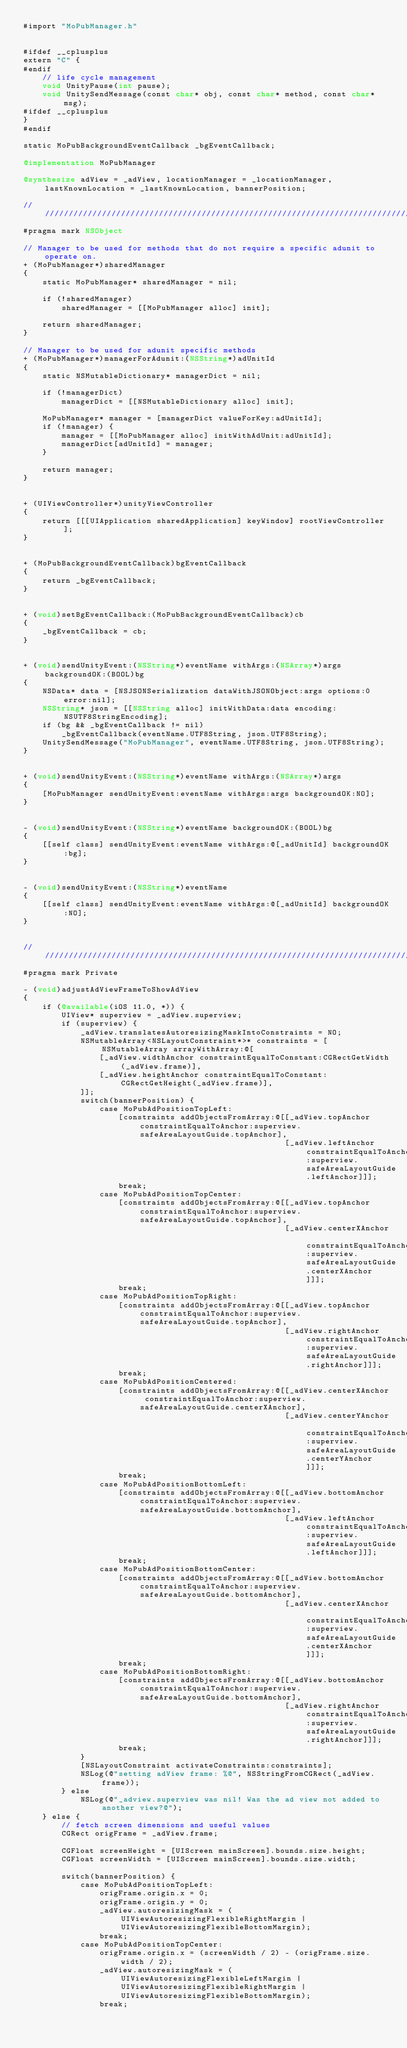<code> <loc_0><loc_0><loc_500><loc_500><_ObjectiveC_>#import "MoPubManager.h"


#ifdef __cplusplus
extern "C" {
#endif
    // life cycle management
    void UnityPause(int pause);
    void UnitySendMessage(const char* obj, const char* method, const char* msg);
#ifdef __cplusplus
}
#endif

static MoPubBackgroundEventCallback _bgEventCallback;

@implementation MoPubManager

@synthesize adView = _adView, locationManager = _locationManager, lastKnownLocation = _lastKnownLocation, bannerPosition;

///////////////////////////////////////////////////////////////////////////////////////////////////
#pragma mark NSObject

// Manager to be used for methods that do not require a specific adunit to operate on.
+ (MoPubManager*)sharedManager
{
    static MoPubManager* sharedManager = nil;

    if (!sharedManager)
        sharedManager = [[MoPubManager alloc] init];

    return sharedManager;
}

// Manager to be used for adunit specific methods
+ (MoPubManager*)managerForAdunit:(NSString*)adUnitId
{
    static NSMutableDictionary* managerDict = nil;

    if (!managerDict)
        managerDict = [[NSMutableDictionary alloc] init];

    MoPubManager* manager = [managerDict valueForKey:adUnitId];
    if (!manager) {
        manager = [[MoPubManager alloc] initWithAdUnit:adUnitId];
        managerDict[adUnitId] = manager;
    }

    return manager;
}


+ (UIViewController*)unityViewController
{
    return [[[UIApplication sharedApplication] keyWindow] rootViewController];
}


+ (MoPubBackgroundEventCallback)bgEventCallback
{
    return _bgEventCallback;
}


+ (void)setBgEventCallback:(MoPubBackgroundEventCallback)cb
{
    _bgEventCallback = cb;
}


+ (void)sendUnityEvent:(NSString*)eventName withArgs:(NSArray*)args backgroundOK:(BOOL)bg
{
    NSData* data = [NSJSONSerialization dataWithJSONObject:args options:0 error:nil];
    NSString* json = [[NSString alloc] initWithData:data encoding:NSUTF8StringEncoding];
    if (bg && _bgEventCallback != nil)
        _bgEventCallback(eventName.UTF8String, json.UTF8String);
    UnitySendMessage("MoPubManager", eventName.UTF8String, json.UTF8String);
}


+ (void)sendUnityEvent:(NSString*)eventName withArgs:(NSArray*)args
{
    [MoPubManager sendUnityEvent:eventName withArgs:args backgroundOK:NO];
}


- (void)sendUnityEvent:(NSString*)eventName backgroundOK:(BOOL)bg
{
    [[self class] sendUnityEvent:eventName withArgs:@[_adUnitId] backgroundOK:bg];
}


- (void)sendUnityEvent:(NSString*)eventName
{
    [[self class] sendUnityEvent:eventName withArgs:@[_adUnitId] backgroundOK:NO];
}


///////////////////////////////////////////////////////////////////////////////////////////////////
#pragma mark Private

- (void)adjustAdViewFrameToShowAdView
{
    if (@available(iOS 11.0, *)) {
        UIView* superview = _adView.superview;
        if (superview) {
            _adView.translatesAutoresizingMaskIntoConstraints = NO;
            NSMutableArray<NSLayoutConstraint*>* constraints = [NSMutableArray arrayWithArray:@[
                [_adView.widthAnchor constraintEqualToConstant:CGRectGetWidth(_adView.frame)],
                [_adView.heightAnchor constraintEqualToConstant:CGRectGetHeight(_adView.frame)],
            ]];
            switch(bannerPosition) {
                case MoPubAdPositionTopLeft:
                    [constraints addObjectsFromArray:@[[_adView.topAnchor constraintEqualToAnchor:superview.safeAreaLayoutGuide.topAnchor],
                                                       [_adView.leftAnchor constraintEqualToAnchor:superview.safeAreaLayoutGuide.leftAnchor]]];
                    break;
                case MoPubAdPositionTopCenter:
                    [constraints addObjectsFromArray:@[[_adView.topAnchor constraintEqualToAnchor:superview.safeAreaLayoutGuide.topAnchor],
                                                       [_adView.centerXAnchor constraintEqualToAnchor:superview.safeAreaLayoutGuide.centerXAnchor]]];
                    break;
                case MoPubAdPositionTopRight:
                    [constraints addObjectsFromArray:@[[_adView.topAnchor constraintEqualToAnchor:superview.safeAreaLayoutGuide.topAnchor],
                                                       [_adView.rightAnchor constraintEqualToAnchor:superview.safeAreaLayoutGuide.rightAnchor]]];
                    break;
                case MoPubAdPositionCentered:
                    [constraints addObjectsFromArray:@[[_adView.centerXAnchor constraintEqualToAnchor:superview.safeAreaLayoutGuide.centerXAnchor],
                                                       [_adView.centerYAnchor constraintEqualToAnchor:superview.safeAreaLayoutGuide.centerYAnchor]]];
                    break;
                case MoPubAdPositionBottomLeft:
                    [constraints addObjectsFromArray:@[[_adView.bottomAnchor constraintEqualToAnchor:superview.safeAreaLayoutGuide.bottomAnchor],
                                                       [_adView.leftAnchor constraintEqualToAnchor:superview.safeAreaLayoutGuide.leftAnchor]]];
                    break;
                case MoPubAdPositionBottomCenter:
                    [constraints addObjectsFromArray:@[[_adView.bottomAnchor constraintEqualToAnchor:superview.safeAreaLayoutGuide.bottomAnchor],
                                                       [_adView.centerXAnchor constraintEqualToAnchor:superview.safeAreaLayoutGuide.centerXAnchor]]];
                    break;
                case MoPubAdPositionBottomRight:
                    [constraints addObjectsFromArray:@[[_adView.bottomAnchor constraintEqualToAnchor:superview.safeAreaLayoutGuide.bottomAnchor],
                                                       [_adView.rightAnchor constraintEqualToAnchor:superview.safeAreaLayoutGuide.rightAnchor]]];
                    break;
            }
            [NSLayoutConstraint activateConstraints:constraints];
            NSLog(@"setting adView frame: %@", NSStringFromCGRect(_adView.frame));
        } else
            NSLog(@"_adview.superview was nil! Was the ad view not added to another view?@");
    } else {
        // fetch screen dimensions and useful values
        CGRect origFrame = _adView.frame;

        CGFloat screenHeight = [UIScreen mainScreen].bounds.size.height;
        CGFloat screenWidth = [UIScreen mainScreen].bounds.size.width;

        switch(bannerPosition) {
            case MoPubAdPositionTopLeft:
                origFrame.origin.x = 0;
                origFrame.origin.y = 0;
                _adView.autoresizingMask = (UIViewAutoresizingFlexibleRightMargin | UIViewAutoresizingFlexibleBottomMargin);
                break;
            case MoPubAdPositionTopCenter:
                origFrame.origin.x = (screenWidth / 2) - (origFrame.size.width / 2);
                _adView.autoresizingMask = (UIViewAutoresizingFlexibleLeftMargin | UIViewAutoresizingFlexibleRightMargin | UIViewAutoresizingFlexibleBottomMargin);
                break;</code> 